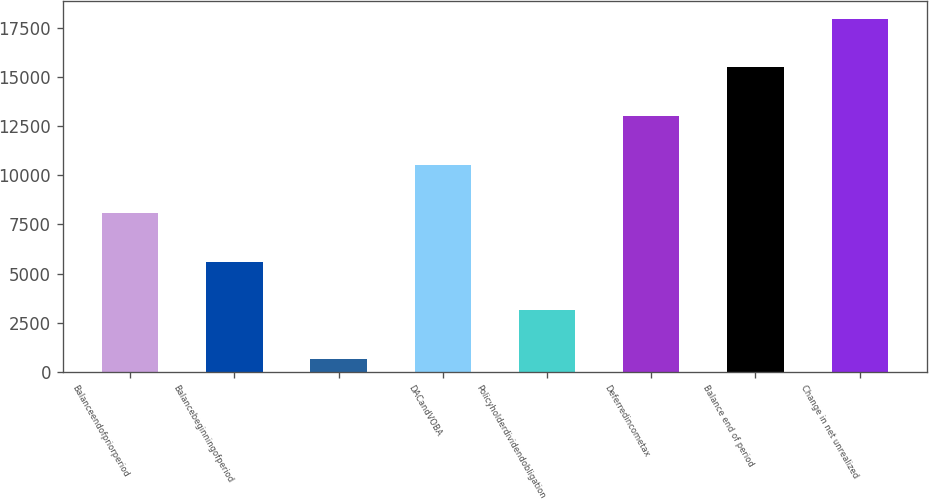Convert chart. <chart><loc_0><loc_0><loc_500><loc_500><bar_chart><fcel>Balanceendofpriorperiod<fcel>Balancebeginningofperiod<fcel>Unnamed: 2<fcel>DACandVOBA<fcel>Policyholderdividendobligation<fcel>Deferredincometax<fcel>Balance end of period<fcel>Change in net unrealized<nl><fcel>8068.1<fcel>5595.4<fcel>650<fcel>10540.8<fcel>3122.7<fcel>13013.5<fcel>15486.2<fcel>17958.9<nl></chart> 